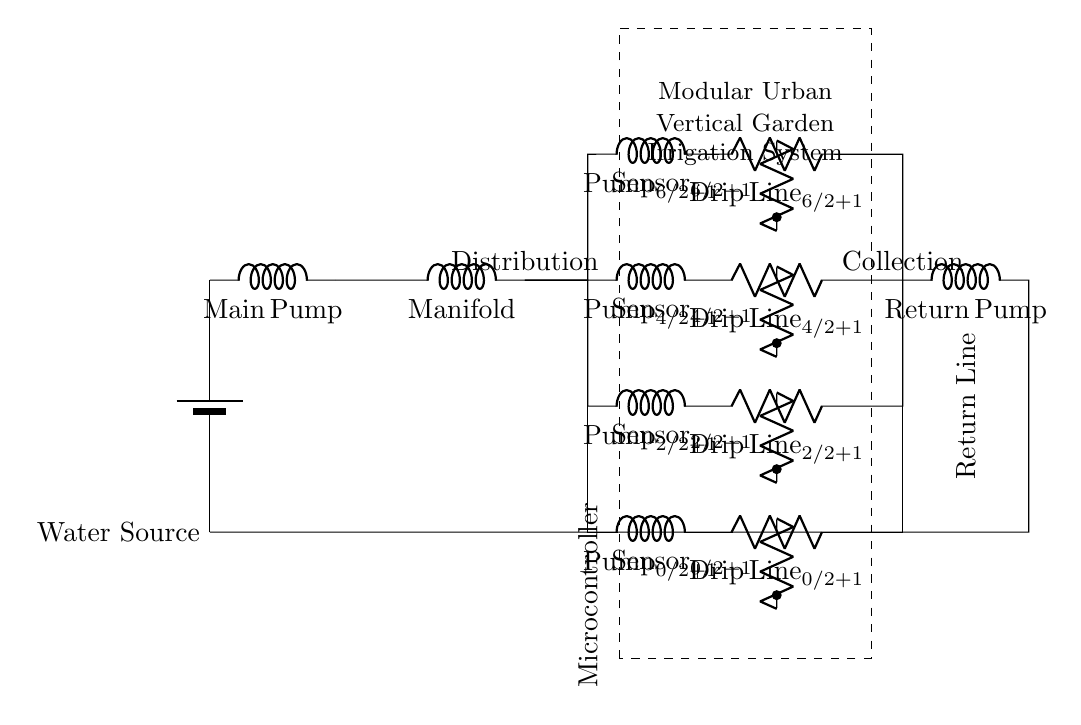What is the main component responsible for distributing water? The component responsible for distributing water is the manifold, which channels water to the various pumps in parallel branches.
Answer: manifold How many parallel pump branches are there? There are four parallel pump branches, as indicated by the four distinct pumps labeled from Pump 1 to Pump 4 in the circuit diagram.
Answer: 4 What is the purpose of the soil moisture sensors? The soil moisture sensors are used to measure the moisture level in the soil, allowing the irrigation system to adjust watering as needed based on the sensor readings.
Answer: moisture measurement Which component returns water to the source? The component that returns water to the source is the return pump, which collects water from the collection line and sends it back to the water source.
Answer: return pump How is the microcontroller involved in this irrigation system? The microcontroller controls the overall operation of the irrigation system, including the management of pumps and sensors based on their readings, ensuring efficient watering.
Answer: control system Explain the significance of using a parallel circuit design in this system. A parallel circuit design allows each pump to operate independently, ensuring that if one pump fails, the others can continue to function. This design increases reliability and efficiency for the irrigation system.
Answer: independent operation 